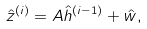<formula> <loc_0><loc_0><loc_500><loc_500>\hat { z } ^ { ( i ) } = A \hat { h } ^ { ( i - 1 ) } + \hat { w } ,</formula> 